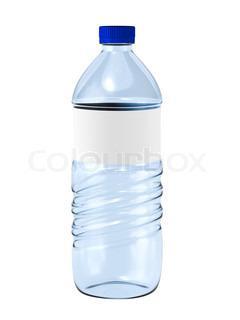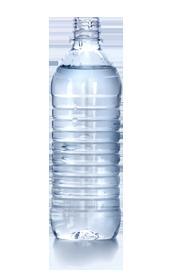The first image is the image on the left, the second image is the image on the right. Examine the images to the left and right. Is the description "An image shows at least one filled water bottle with a blue lid and no label." accurate? Answer yes or no. No. 